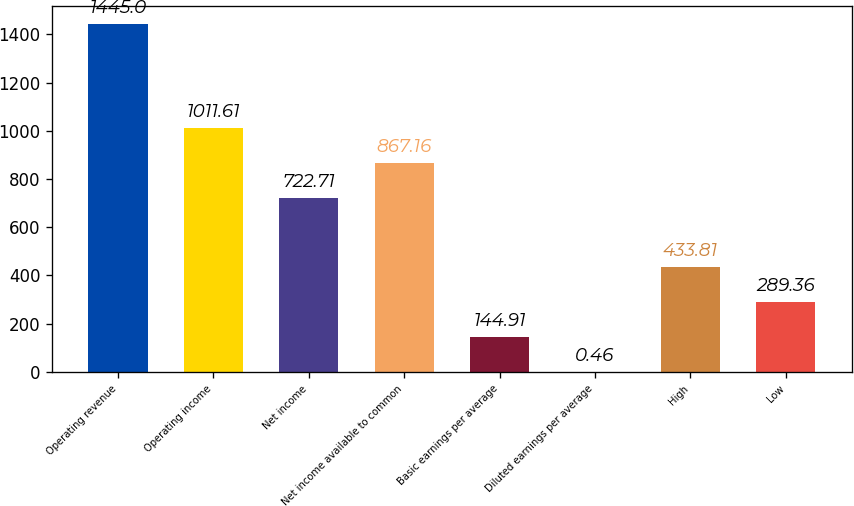Convert chart to OTSL. <chart><loc_0><loc_0><loc_500><loc_500><bar_chart><fcel>Operating revenue<fcel>Operating income<fcel>Net income<fcel>Net income available to common<fcel>Basic earnings per average<fcel>Diluted earnings per average<fcel>High<fcel>Low<nl><fcel>1445<fcel>1011.61<fcel>722.71<fcel>867.16<fcel>144.91<fcel>0.46<fcel>433.81<fcel>289.36<nl></chart> 